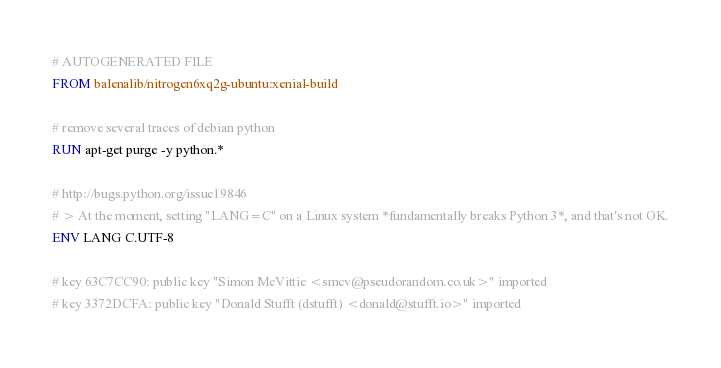Convert code to text. <code><loc_0><loc_0><loc_500><loc_500><_Dockerfile_># AUTOGENERATED FILE
FROM balenalib/nitrogen6xq2g-ubuntu:xenial-build

# remove several traces of debian python
RUN apt-get purge -y python.*

# http://bugs.python.org/issue19846
# > At the moment, setting "LANG=C" on a Linux system *fundamentally breaks Python 3*, and that's not OK.
ENV LANG C.UTF-8

# key 63C7CC90: public key "Simon McVittie <smcv@pseudorandom.co.uk>" imported
# key 3372DCFA: public key "Donald Stufft (dstufft) <donald@stufft.io>" imported</code> 